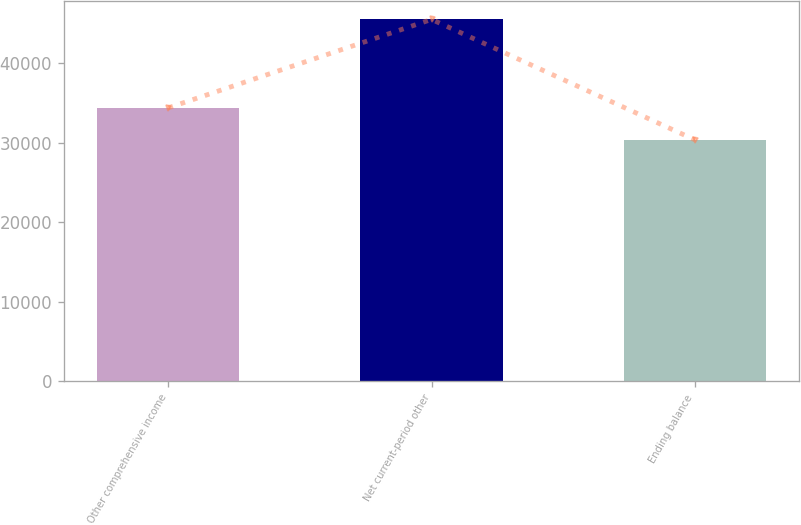Convert chart. <chart><loc_0><loc_0><loc_500><loc_500><bar_chart><fcel>Other comprehensive income<fcel>Net current-period other<fcel>Ending balance<nl><fcel>34400<fcel>45535<fcel>30374<nl></chart> 